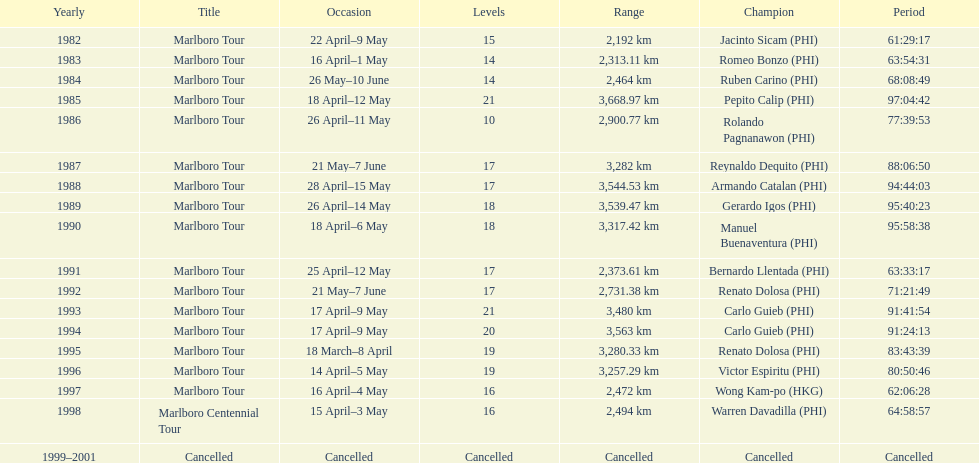Which year did warren davdilla (w.d.) appear? 1998. What tour did w.d. complete? Marlboro Centennial Tour. What is the time recorded in the same row as w.d.? 64:58:57. 